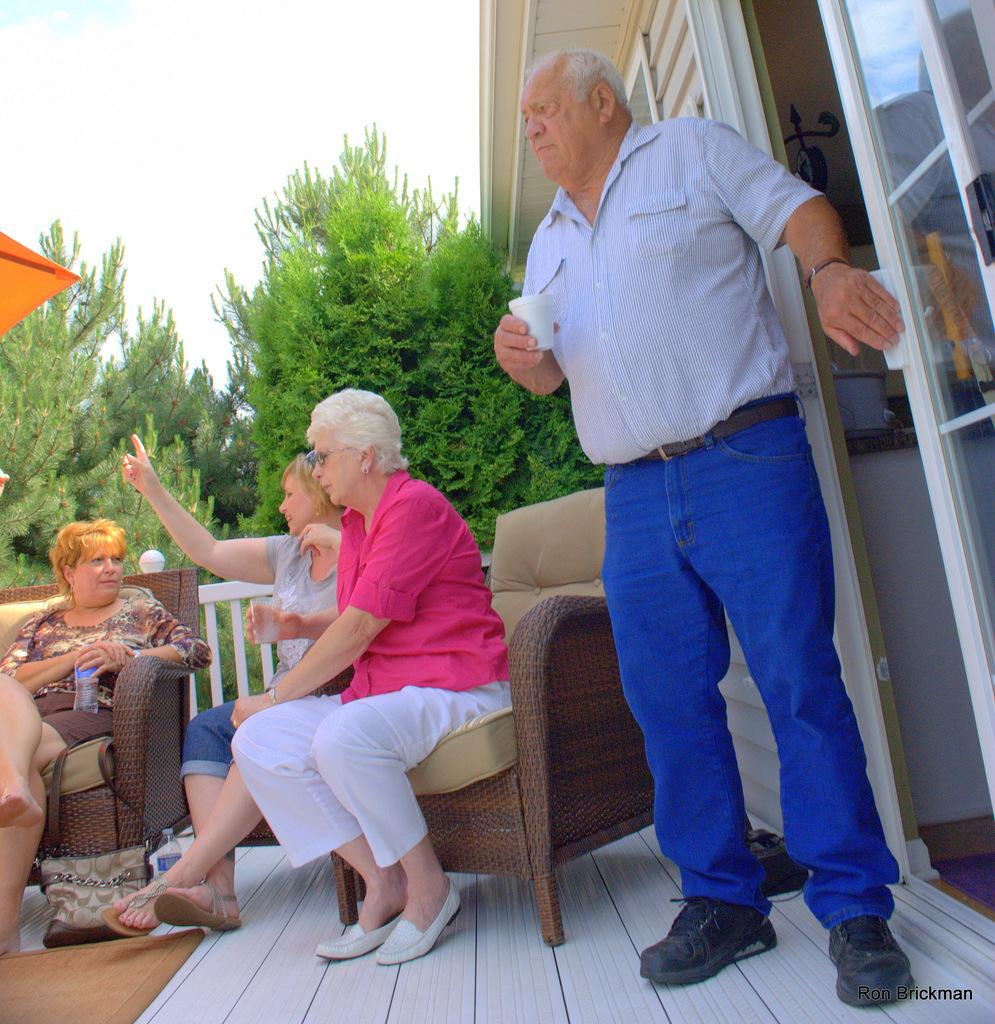What is the man on the right side of the image doing? The man is standing on the right side of the image and holding a cup. What are the other people in the image doing? The other people in the image are sitting on the left side. What type of pen is the man using to draw a picture in the image? There is no pen or picture present in the image; the man is simply holding a cup. 